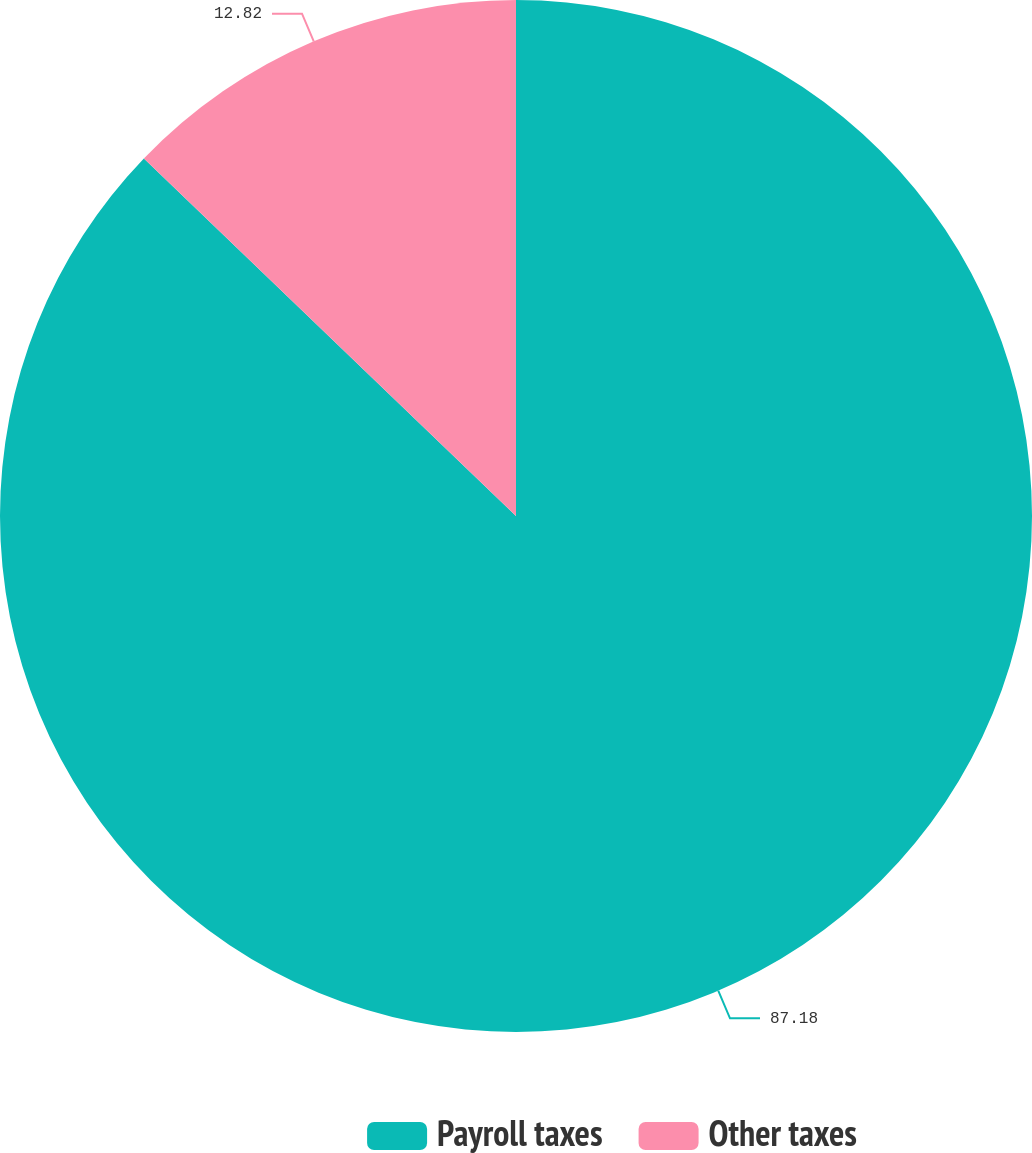Convert chart to OTSL. <chart><loc_0><loc_0><loc_500><loc_500><pie_chart><fcel>Payroll taxes<fcel>Other taxes<nl><fcel>87.18%<fcel>12.82%<nl></chart> 